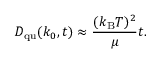<formula> <loc_0><loc_0><loc_500><loc_500>D _ { q u } ( k _ { 0 } , t ) \approx { \frac { ( k _ { B } T ) ^ { 2 } } { \mu } } t .</formula> 